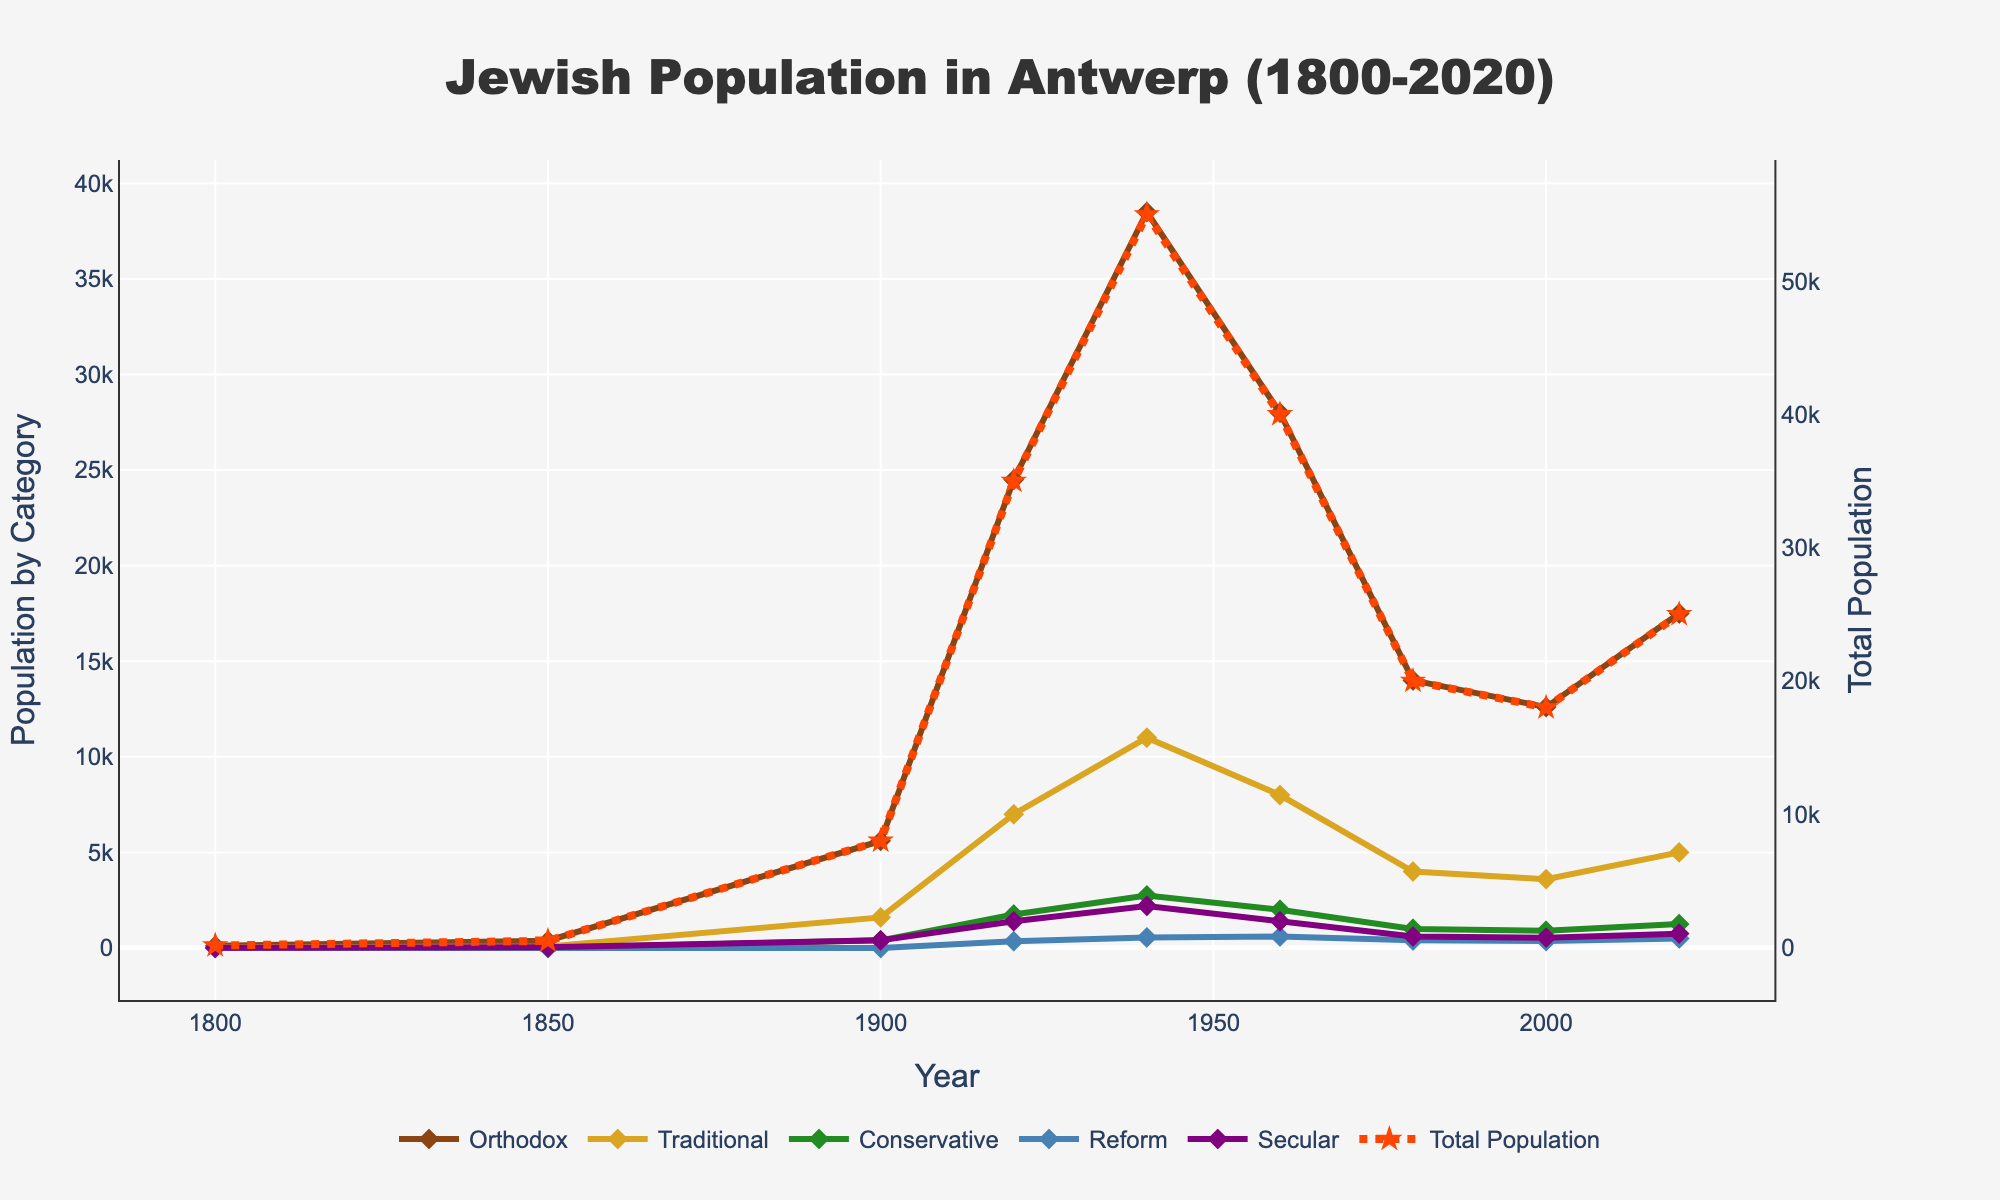Which population subgroup showed the highest number in the year 1980? To determine this, look at the year 1980 on the x-axis and identify the line that peaks highest on the y-axis corresponding to the different subgroups. The Orthodox group had the highest peak in 1980.
Answer: Orthodox Has the total Jewish population in Antwerp increased or decreased from 1960 to 1980? Locate the years 1960 and 1980 on the x-axis, then observe the line representing the total population. The line shows a descending trend from 1960 to 1980.
Answer: Decreased What is the difference in the Traditional Jewish population between 1920 and 1980? Find the y-values for the Traditional subgroup in the years 1920 and 1980. Subtract the 1980 value from the 1920 value: 7000 - 4000.
Answer: 3000 Which subgroup had a population increase from 2000 to 2020? Locate the years 2000 and 2020 and observe the lines for each subgroup. Only the Orthodox line shows an upward trend between these years.
Answer: Orthodox In which year did the total Jewish population in Antwerp reach its peak, and what was the value? Find the highest point on the line representing the total population. The peak occurs in 1940 with a population of 55,000.
Answer: 1940, 55,000 Compare the population of the Secular subgroup in 1800 and 2020. Which year had a higher population? Locate the y-values for the Secular subgroup in 1800 and 2020 on the chart. The values are 10 (1800) and 750 (2020), showing a higher population in 2020.
Answer: 2020 What is the average population of the Conservative subgroup from 1920 to 2020? Identify the y-values for the Conservative subgroup in these years: 1920 (1750), 1960 (2000), 1980 (1000), 2000 (900), 2020 (1250). Sum them and divide by 5: (1750+2000+1000+900+1250)/5.
Answer: 1380 Which subgroup had the least change in population between 1800 and 2020? Calculate the difference in population for each subgroup between these years. The Secular group had the least change: 750 - 10 = 740.
Answer: Secular In which decade did the Orthodox subgroup first exceed a population of 30,000? Monitor the y-values of the Orthodox subgroup by decade on the x-axis. The first occurrence over 30,000 is in the 1930s.
Answer: 1930s 